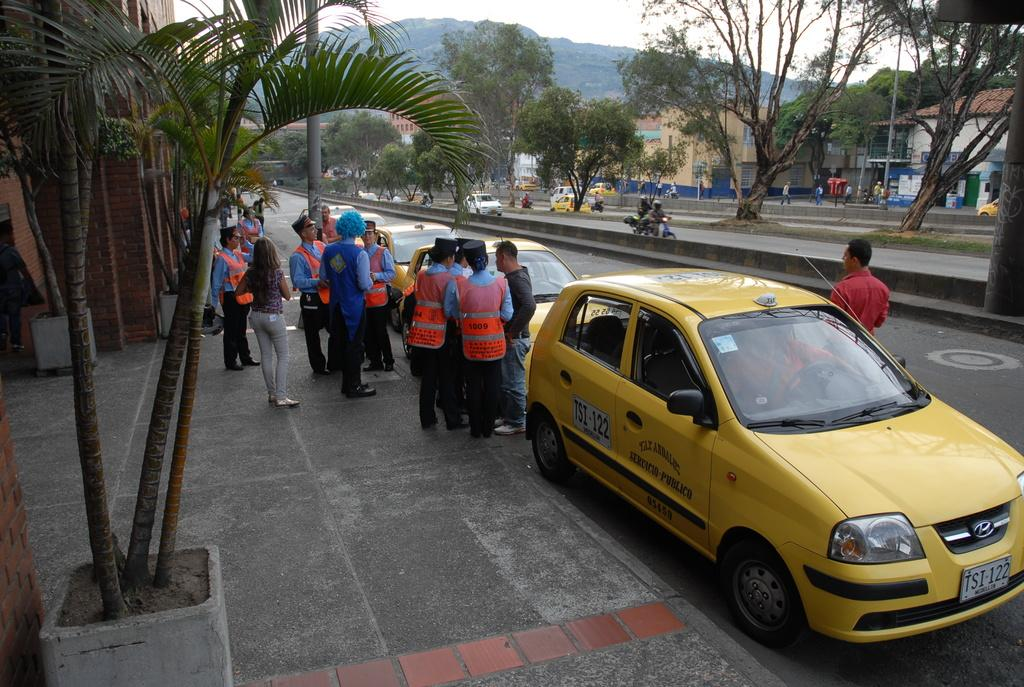Provide a one-sentence caption for the provided image. Yellow tax with the call signs TSI-122 in front of a building. 